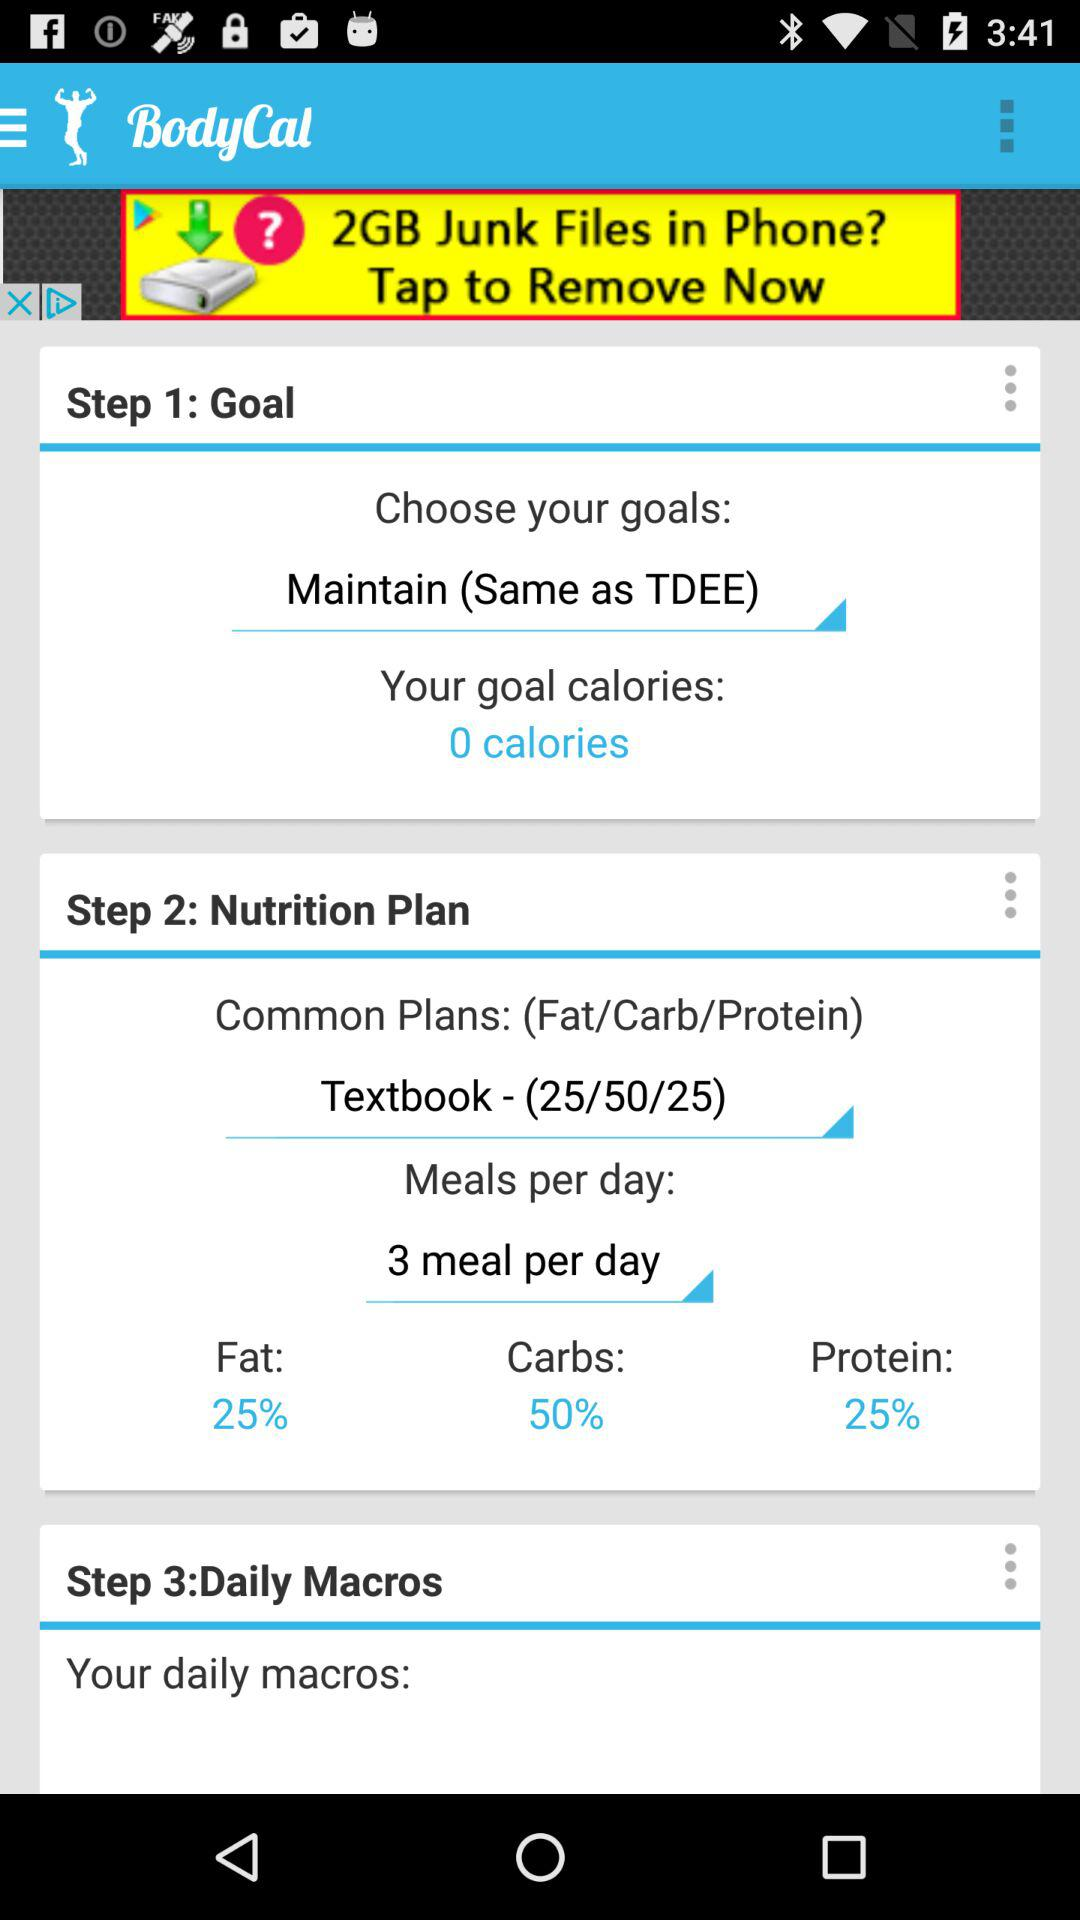How many percent of calories are from fat?
Answer the question using a single word or phrase. 25% 